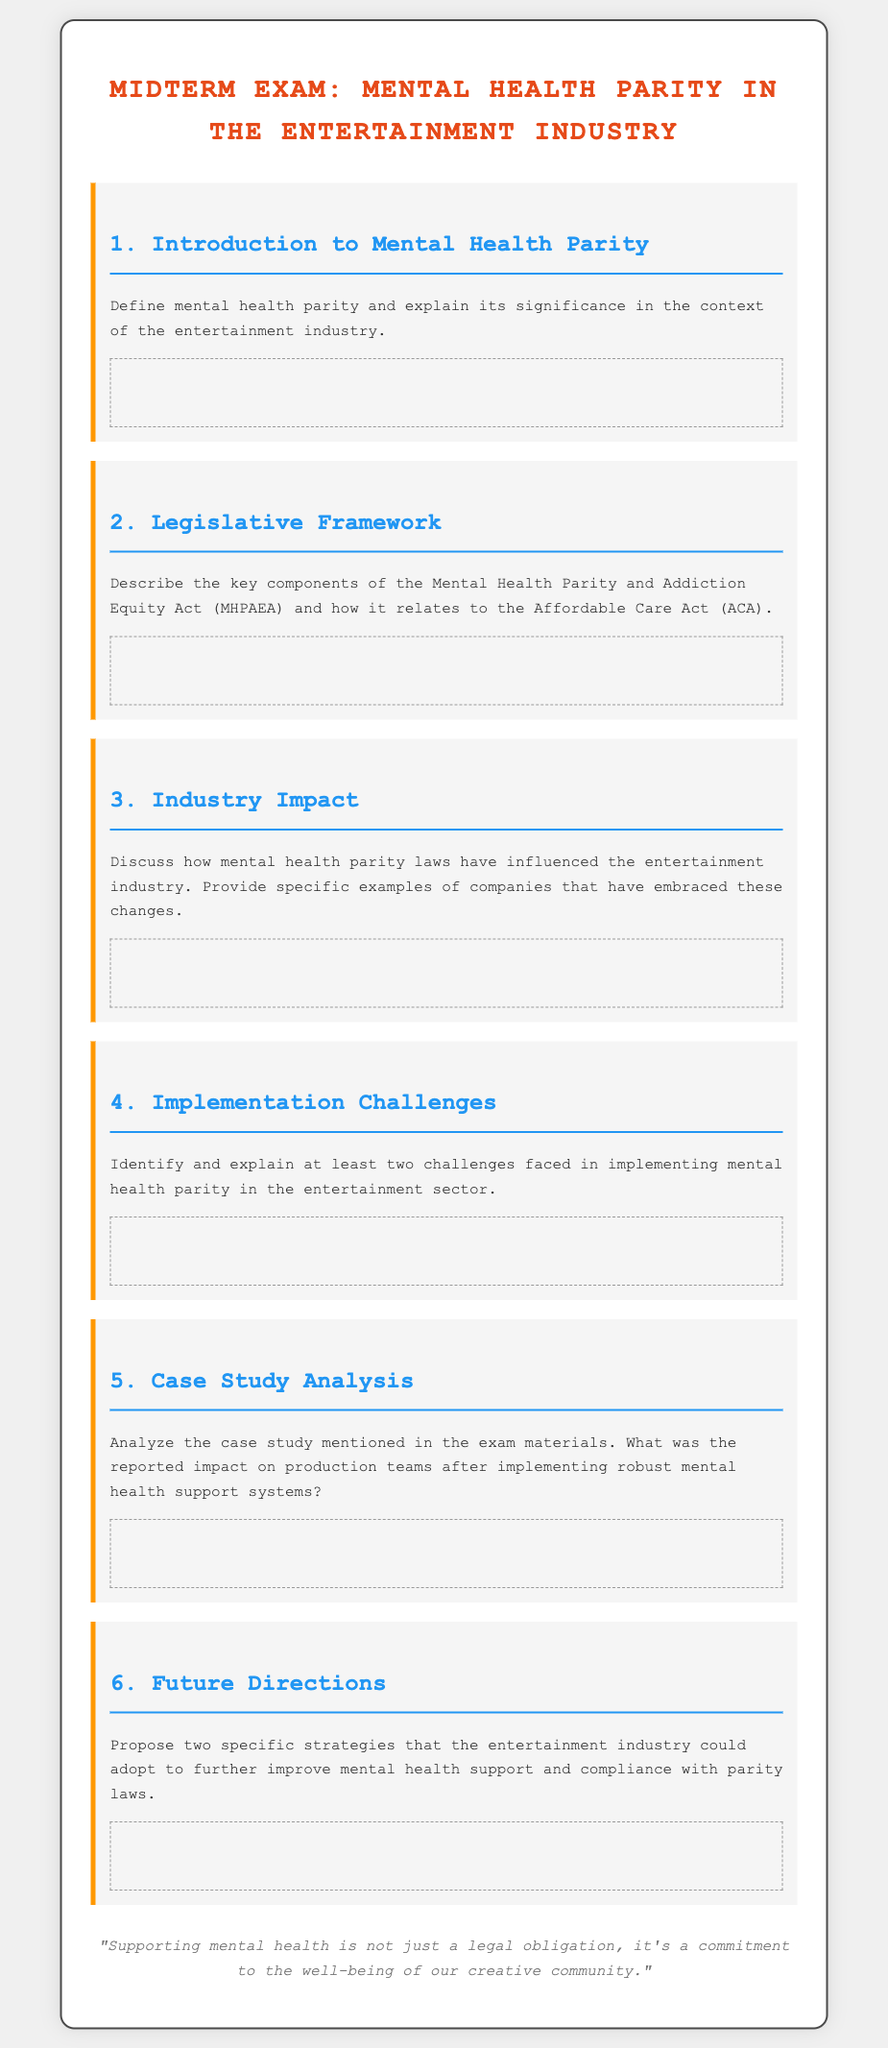What is the title of the exam? The title displayed at the top of the document indicates the subject of the exam, which is concerned with mental health in the entertainment industry.
Answer: Midterm Exam: Mental Health Parity in the Entertainment Industry How many questions are included in the exam? The document outlines six distinct questions in total.
Answer: 6 What is the color of the headings in the document? The document specifies the color of headings as part of its styling, indicating a consistent visual theme.
Answer: Blue What does MHPAEA stand for? The document refers to a specific legislative act that is vital in discussing mental health parity, abbreviated for conciseness.
Answer: Mental Health Parity and Addiction Equity Act What is the first topic of question 1 in the exam? The topic of question 1 deals with defining a key concept central to the exam's focus, as stated in the document.
Answer: Introduction to Mental Health Parity What is a proposed specific strategy for improving mental health support? The document encourages students to think critically about forward-thinking approaches related to mental health in the industry.
Answer: Two specific strategies What is the aesthetic style of the exam described? The style of the document aims to convey a professional and educational environment suitable for a midterm examination.
Answer: Monospace font, with a structured layout What color is used for the background of the document? The background color is clearly defined in the styling portion so that it supports readability and visual comfort.
Answer: Light gray 